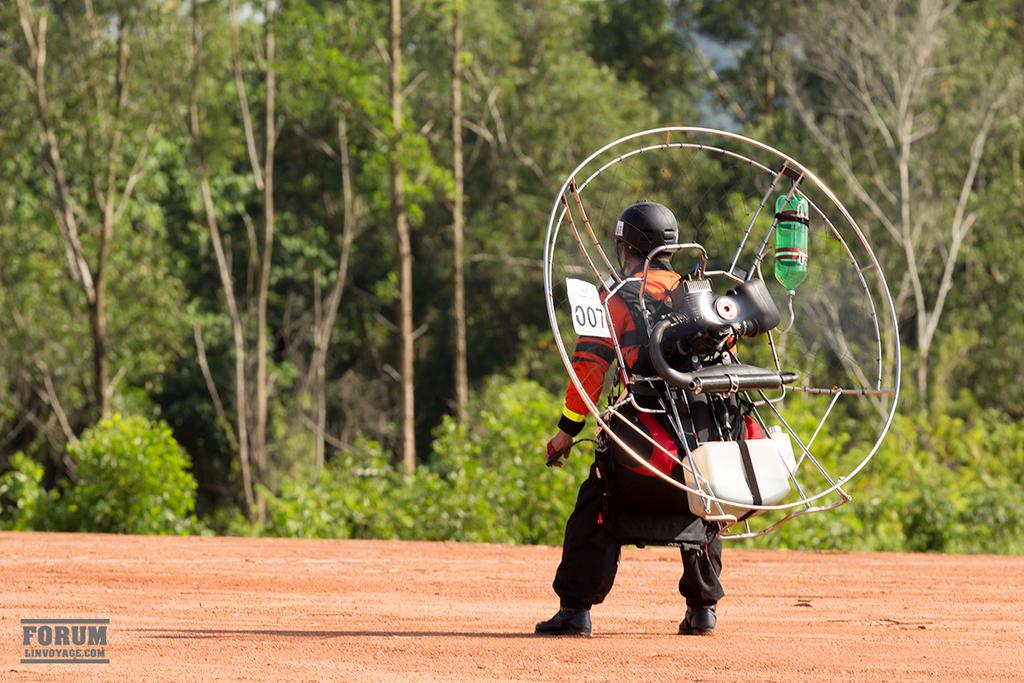What is one of the objects visible in the image? There is a bottle in the image. What type of adhesive item can be seen in the image? There is a sticker in the image. What type of protective gear is visible in the image? There is a helmet in the image. What type of footwear is visible in the image? There are shoes in the image. What other objects can be seen in the image besides the ones mentioned? There are other objects in the image. What is the person in the image standing on? The person is standing on the ground in the image. What type of vegetation can be seen in the background of the image? There are trees visible in the background of the image. What type of liquid is being rewarded to the person in the image? There is no liquid being rewarded to the person in the image. What type of plants are growing on the person's head in the image? There are no plants growing on the person's head in the image. 